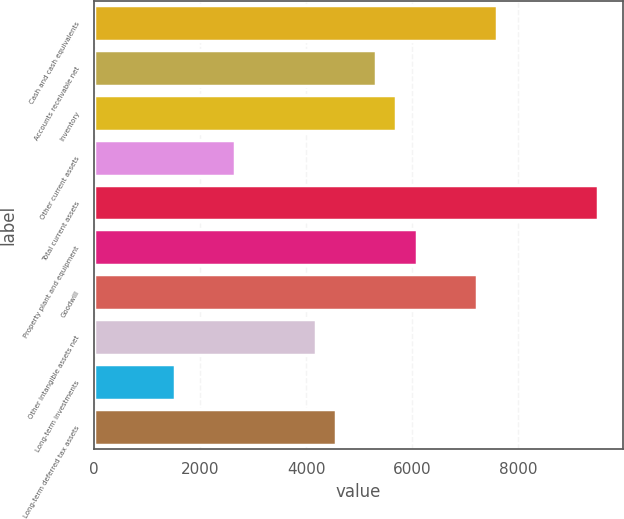Convert chart to OTSL. <chart><loc_0><loc_0><loc_500><loc_500><bar_chart><fcel>Cash and cash equivalents<fcel>Accounts receivable net<fcel>Inventory<fcel>Other current assets<fcel>Total current assets<fcel>Property plant and equipment<fcel>Goodwill<fcel>Other intangible assets net<fcel>Long-term investments<fcel>Long-term deferred tax assets<nl><fcel>7604<fcel>5323.4<fcel>5703.5<fcel>2662.7<fcel>9504.5<fcel>6083.6<fcel>7223.9<fcel>4183.1<fcel>1522.4<fcel>4563.2<nl></chart> 